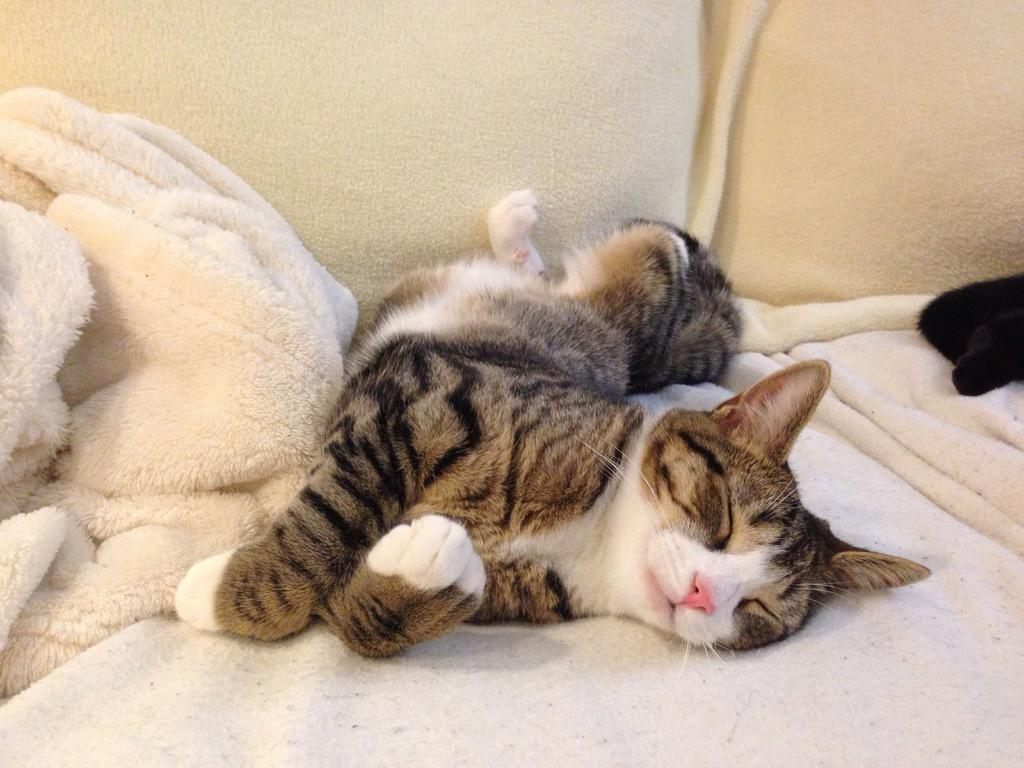What type of animal is in the image? There is a cat in the image. What is the cat doing in the image? The cat is sleeping. Where is the cat located in the image? The cat is on a sofa. How is the cat positioned in the image? The cat is in the center of the image. What language is the cat speaking in the image? Cats do not speak human languages, so it is not possible to determine what language the cat might be speaking in the image. Can you see a basketball in the image? There is no basketball present in the image. 